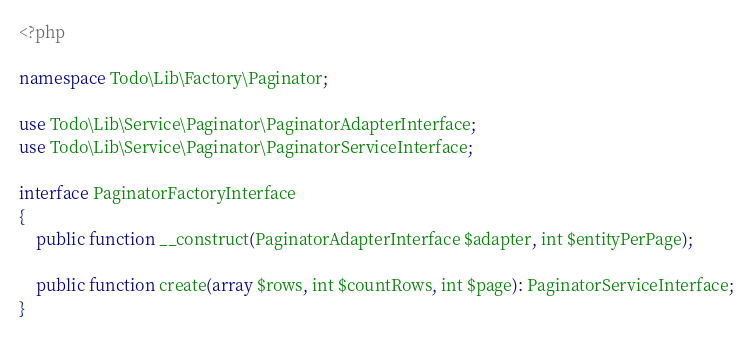<code> <loc_0><loc_0><loc_500><loc_500><_PHP_><?php

namespace Todo\Lib\Factory\Paginator;

use Todo\Lib\Service\Paginator\PaginatorAdapterInterface;
use Todo\Lib\Service\Paginator\PaginatorServiceInterface;

interface PaginatorFactoryInterface
{
    public function __construct(PaginatorAdapterInterface $adapter, int $entityPerPage);

    public function create(array $rows, int $countRows, int $page): PaginatorServiceInterface;
}
</code> 